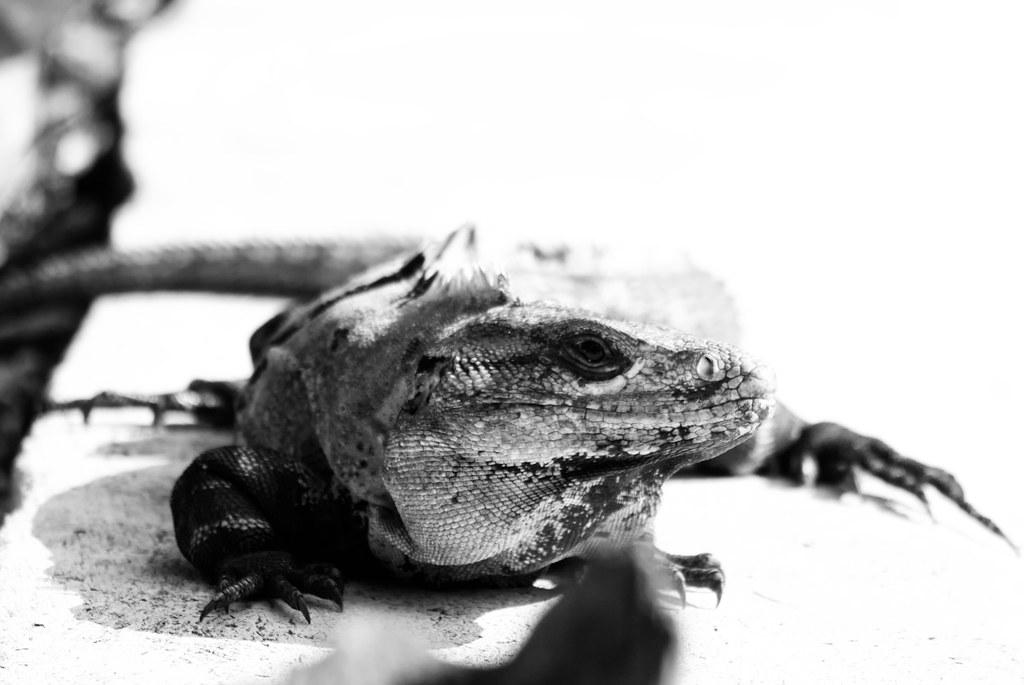What is the color scheme of the image? The image is black and white. What type of animal is in the image? There is a reptile in the image. What is the reptile resting on or interacting with? The reptile is on an object. How would you describe the background of the image? The background of the image is blurred. What role does the governor play in the history of the reptile in the image? There is no governor or reference to history in the image; it only features a reptile on an object with a black and white color scheme and a blurred background. 